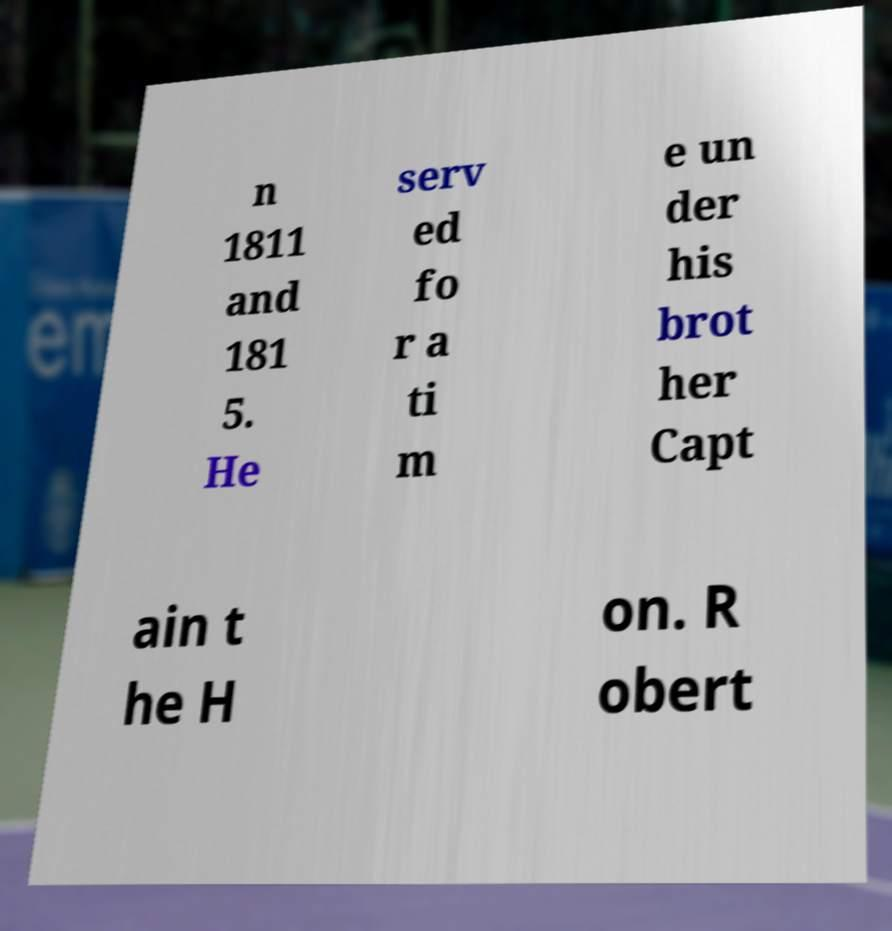Could you assist in decoding the text presented in this image and type it out clearly? n 1811 and 181 5. He serv ed fo r a ti m e un der his brot her Capt ain t he H on. R obert 